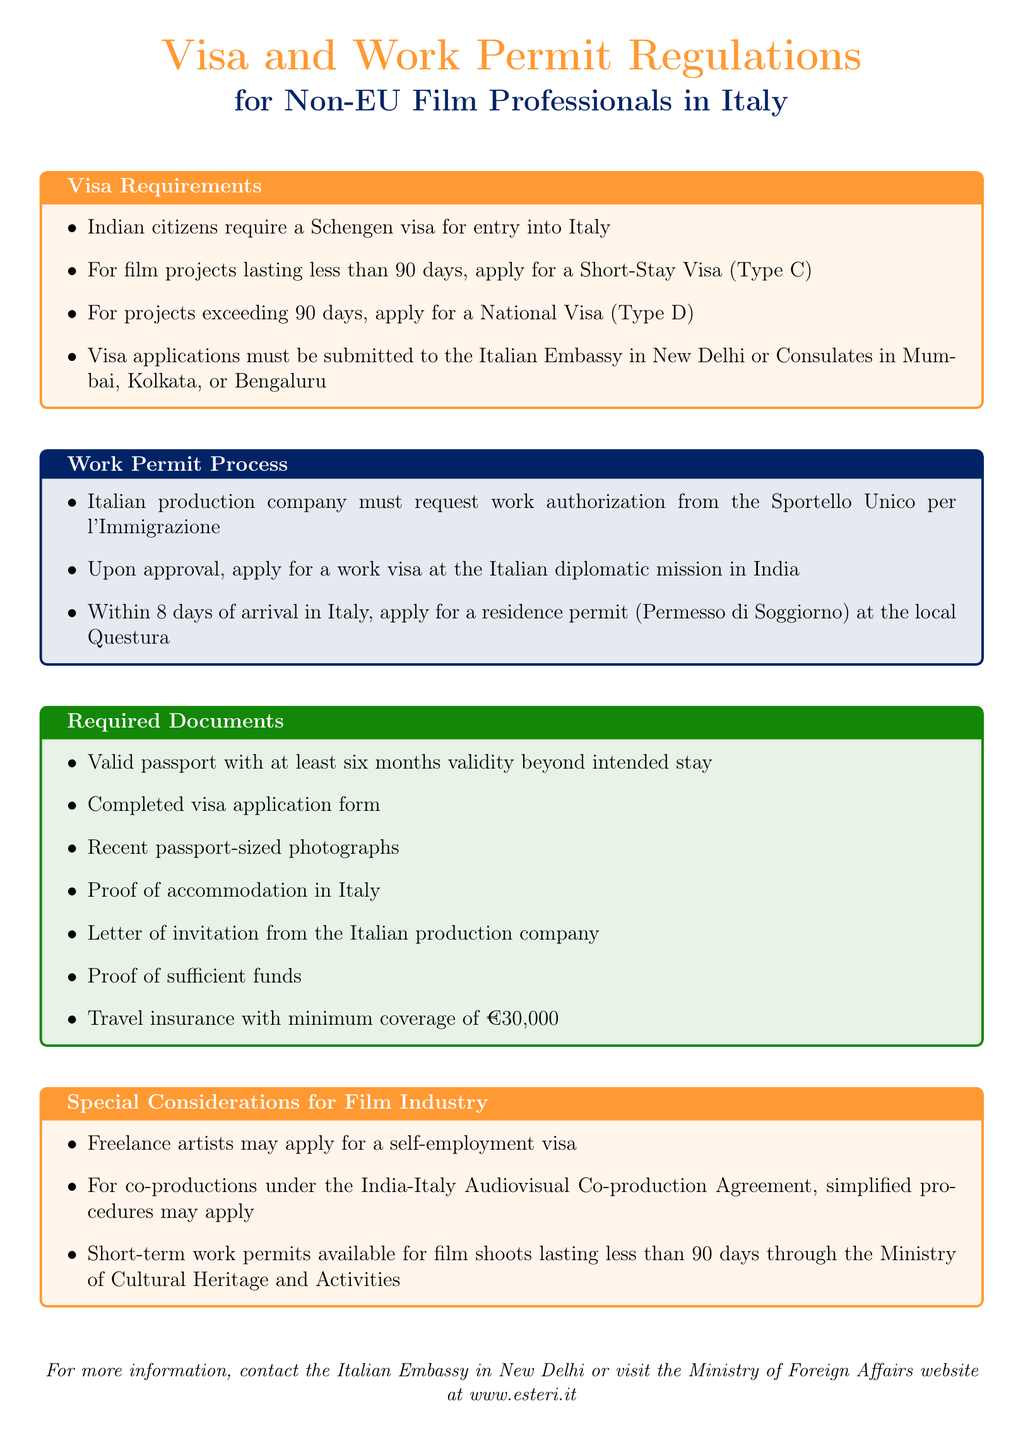What type of visa do Indian citizens need for entry into Italy? The document states that Indian citizens require a Schengen visa for entry into Italy.
Answer: Schengen visa What is the validity period for a Short-Stay Visa? The document specifies that a Short-Stay Visa is for film projects lasting less than 90 days.
Answer: Less than 90 days Where must visa applications be submitted for film professionals from India? The document mentions that visa applications must be submitted to the Italian Embassy in New Delhi or Consulates in Mumbai, Kolkata, or Bengaluru.
Answer: Italian Embassy in New Delhi or Consulates in Mumbai, Kolkata, or Bengaluru What is required within 8 days of arrival in Italy? According to the document, you must apply for a residence permit (Permesso di Soggiorno) within 8 days of arrival in Italy.
Answer: Residence permit (Permesso di Soggiorno) What special visa can freelance artists apply for? The document states that freelance artists may apply for a self-employment visa.
Answer: Self-employment visa What proof is needed regarding accommodation? The document specifies that proof of accommodation in Italy is required.
Answer: Proof of accommodation How much minimum travel insurance coverage is required? The document mentions that travel insurance with a minimum coverage of €30,000 is necessary.
Answer: €30,000 Which ministry provides short-term work permits for film shoots? The document indicates that short-term work permits are available through the Ministry of Cultural Heritage and Activities.
Answer: Ministry of Cultural Heritage and Activities What document is needed from an Italian production company? The document states that a letter of invitation from the Italian production company is necessary.
Answer: Letter of invitation 